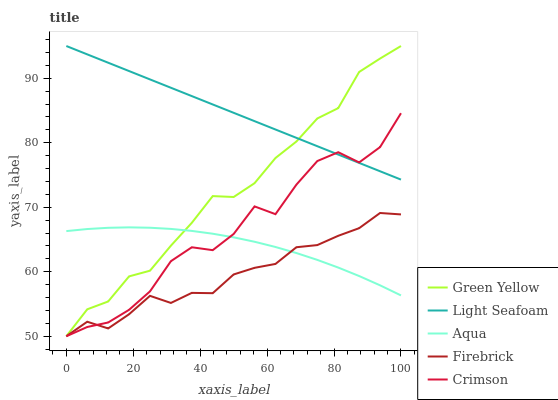Does Firebrick have the minimum area under the curve?
Answer yes or no. Yes. Does Light Seafoam have the maximum area under the curve?
Answer yes or no. Yes. Does Green Yellow have the minimum area under the curve?
Answer yes or no. No. Does Green Yellow have the maximum area under the curve?
Answer yes or no. No. Is Light Seafoam the smoothest?
Answer yes or no. Yes. Is Crimson the roughest?
Answer yes or no. Yes. Is Firebrick the smoothest?
Answer yes or no. No. Is Firebrick the roughest?
Answer yes or no. No. Does Crimson have the lowest value?
Answer yes or no. Yes. Does Aqua have the lowest value?
Answer yes or no. No. Does Light Seafoam have the highest value?
Answer yes or no. Yes. Does Firebrick have the highest value?
Answer yes or no. No. Is Firebrick less than Light Seafoam?
Answer yes or no. Yes. Is Light Seafoam greater than Firebrick?
Answer yes or no. Yes. Does Aqua intersect Green Yellow?
Answer yes or no. Yes. Is Aqua less than Green Yellow?
Answer yes or no. No. Is Aqua greater than Green Yellow?
Answer yes or no. No. Does Firebrick intersect Light Seafoam?
Answer yes or no. No. 